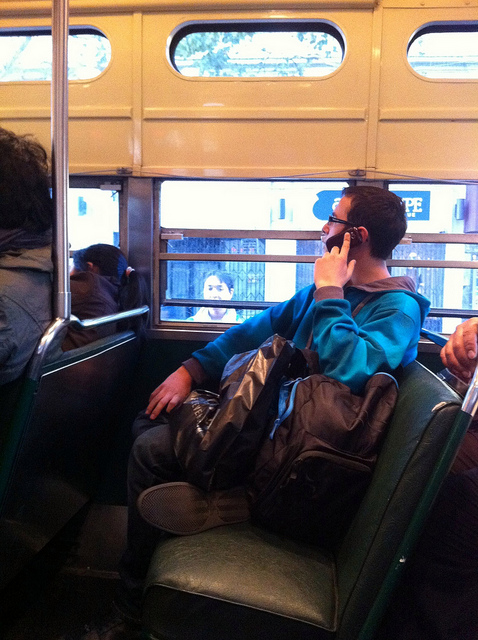Extract all visible text content from this image. PE ELEVEL 